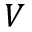Convert formula to latex. <formula><loc_0><loc_0><loc_500><loc_500>V</formula> 